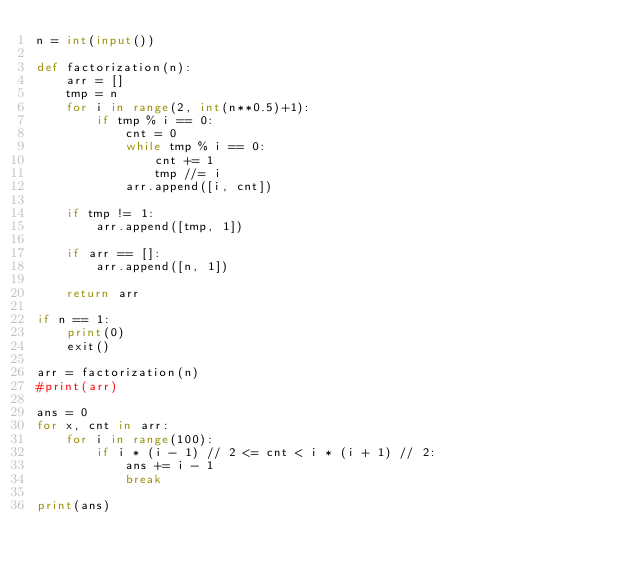<code> <loc_0><loc_0><loc_500><loc_500><_Python_>n = int(input())

def factorization(n):
    arr = []
    tmp = n
    for i in range(2, int(n**0.5)+1):
        if tmp % i == 0:
            cnt = 0
            while tmp % i == 0:
                cnt += 1
                tmp //= i
            arr.append([i, cnt])

    if tmp != 1:
        arr.append([tmp, 1])

    if arr == []:
        arr.append([n, 1])

    return arr

if n == 1:
    print(0)
    exit()

arr = factorization(n)
#print(arr)

ans = 0
for x, cnt in arr:
    for i in range(100):
        if i * (i - 1) // 2 <= cnt < i * (i + 1) // 2:
            ans += i - 1
            break

print(ans)</code> 